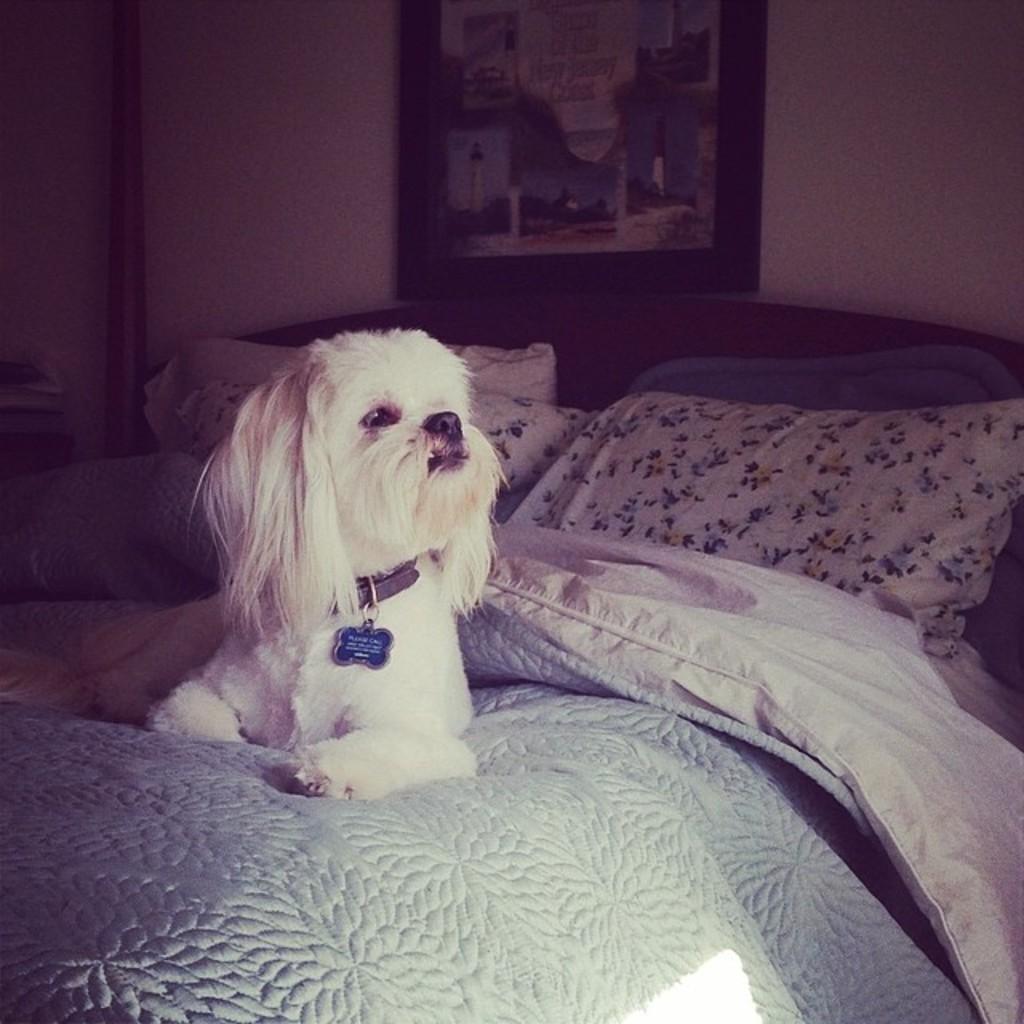How would you summarize this image in a sentence or two? In this image there is a dog sitting in a bed , there is blanket , pillow, frame attached to wall. 